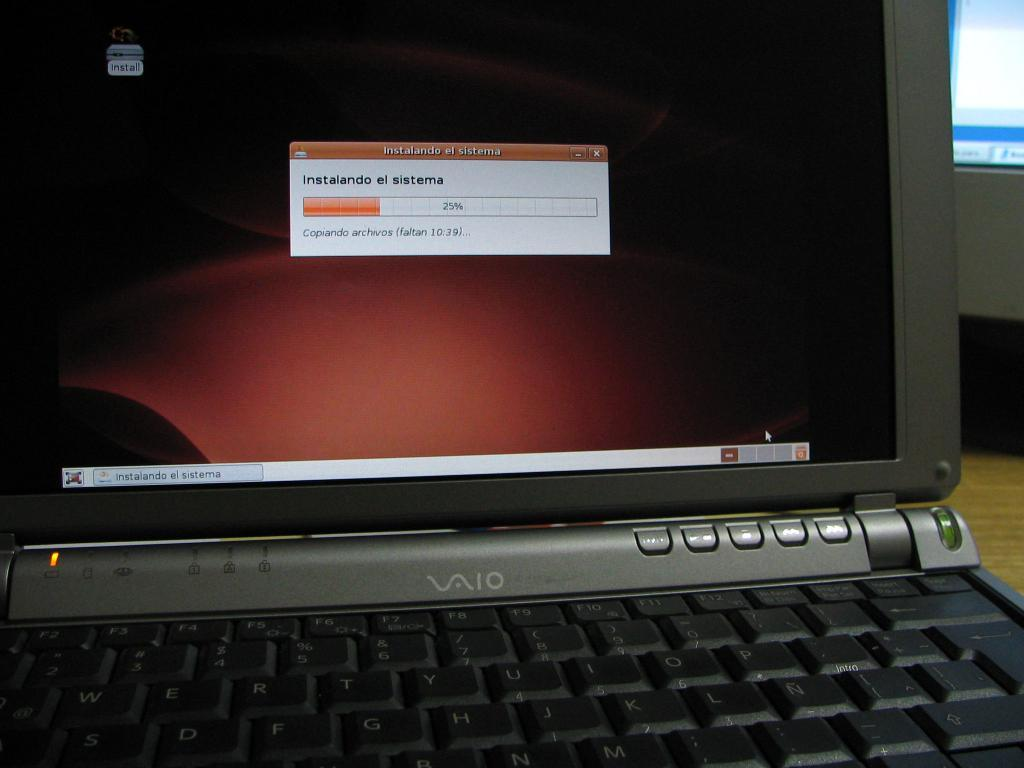<image>
Provide a brief description of the given image. A VAIO laptop displaying a downloading message on the screen. 